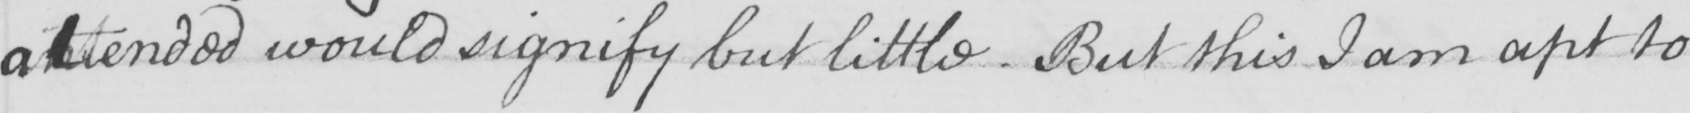Please transcribe the handwritten text in this image. attended would signify but little . But this I am apt to 